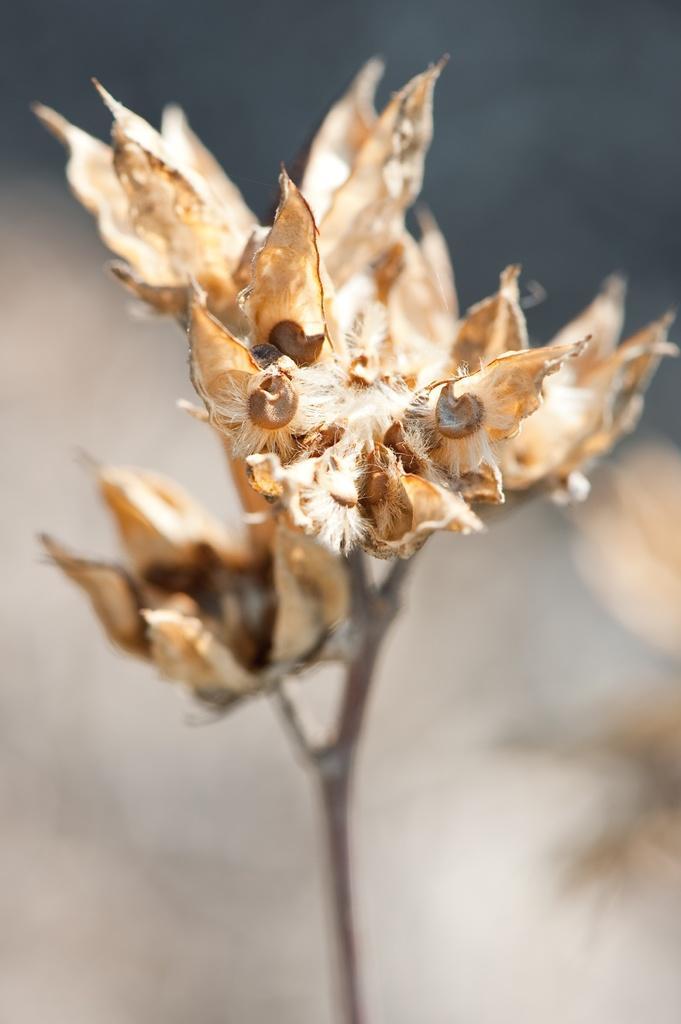Please provide a concise description of this image. In this image we can see a plant. There is a blur background in the image. 